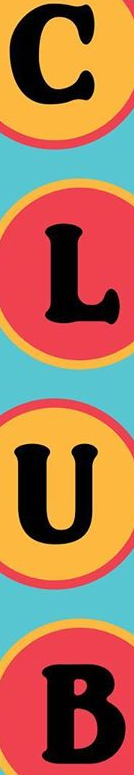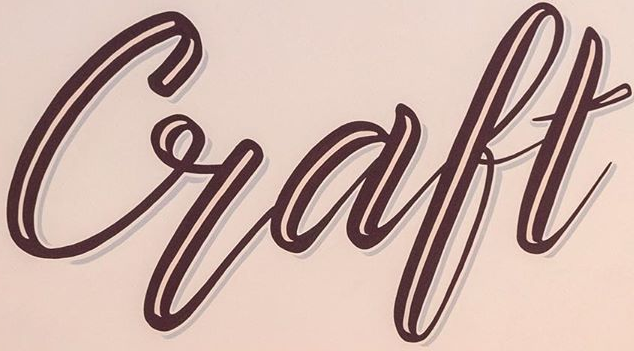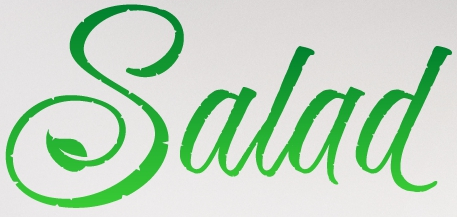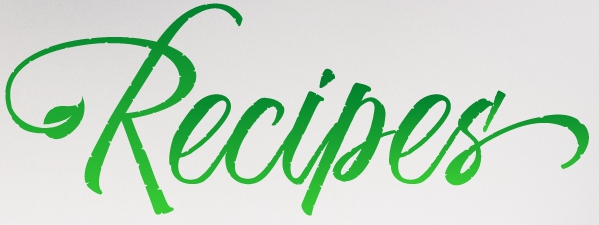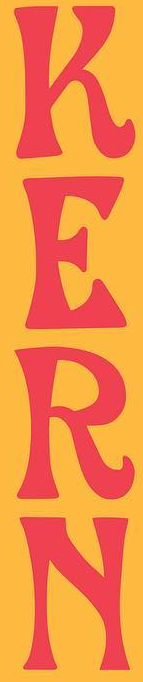What words can you see in these images in sequence, separated by a semicolon? CLUB; Craft; Salad; Recipes'; KERN 